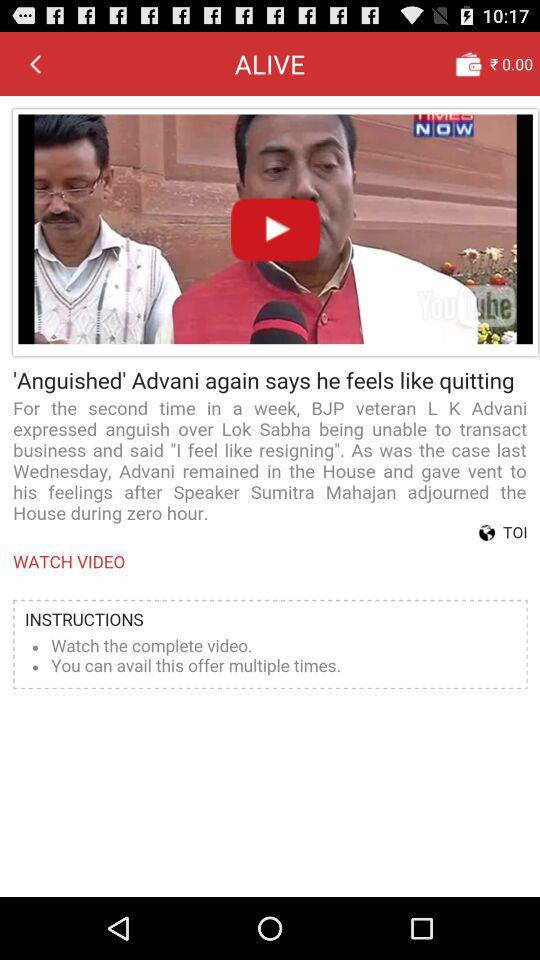How long is the video?
When the provided information is insufficient, respond with <no answer>. <no answer> 